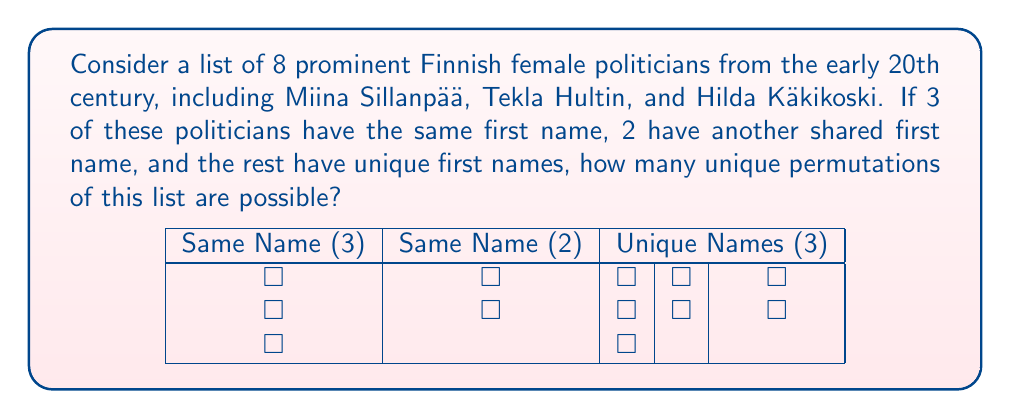Give your solution to this math problem. Let's approach this step-by-step using the principles of permutations with repetition:

1) We have a total of 8 politicians.

2) The distribution of names is as follows:
   - 3 politicians share one name
   - 2 politicians share another name
   - 3 politicians have unique names

3) To calculate the number of unique permutations, we use the formula:

   $$\frac{n!}{n_1! \cdot n_2! \cdot ... \cdot n_k!}$$

   Where:
   - $n$ is the total number of items
   - $n_1, n_2, ..., n_k$ are the numbers of each repeated item

4) In our case:
   $n = 8$
   $n_1 = 3$ (for the name repeated 3 times)
   $n_2 = 2$ (for the name repeated 2 times)
   The other 3 names are unique, so they don't affect the denominator.

5) Plugging these values into our formula:

   $$\frac{8!}{3! \cdot 2!}$$

6) Let's calculate this:
   $$\frac{8 \cdot 7 \cdot 6 \cdot 5 \cdot 4 \cdot 3 \cdot 2 \cdot 1}{(3 \cdot 2 \cdot 1) \cdot (2 \cdot 1)}$$

7) Simplify:
   $$\frac{40320}{12}$$

8) Final result:
   $$3360$$

Thus, there are 3360 unique permutations possible for this list of Finnish female politicians.
Answer: 3360 